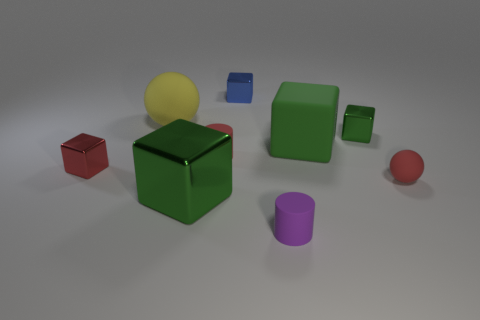There is a metal object that is behind the green matte object and to the left of the large green matte cube; what is its shape?
Keep it short and to the point. Cube. What material is the other large block that is the same color as the big metal block?
Offer a terse response. Rubber. What number of spheres are red rubber objects or yellow things?
Offer a terse response. 2. There is a rubber block that is the same color as the large metal block; what size is it?
Keep it short and to the point. Large. Is the number of metallic things to the right of the small matte sphere less than the number of big red matte objects?
Keep it short and to the point. No. The large object that is behind the red matte sphere and left of the purple cylinder is what color?
Make the answer very short. Yellow. What number of other objects are there of the same shape as the red shiny thing?
Ensure brevity in your answer.  4. Is the number of small green metallic things on the left side of the tiny blue object less than the number of large matte cubes that are behind the big matte block?
Your answer should be very brief. No. Does the small purple cylinder have the same material as the tiny thing behind the tiny green cube?
Your response must be concise. No. Are there more purple matte objects than blue rubber balls?
Offer a very short reply. Yes. 